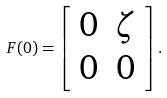Convert formula to latex. <formula><loc_0><loc_0><loc_500><loc_500>F ( 0 ) = \left [ \begin{array} { c c } 0 & \zeta \\ 0 & 0 \end{array} \right ] .</formula> 